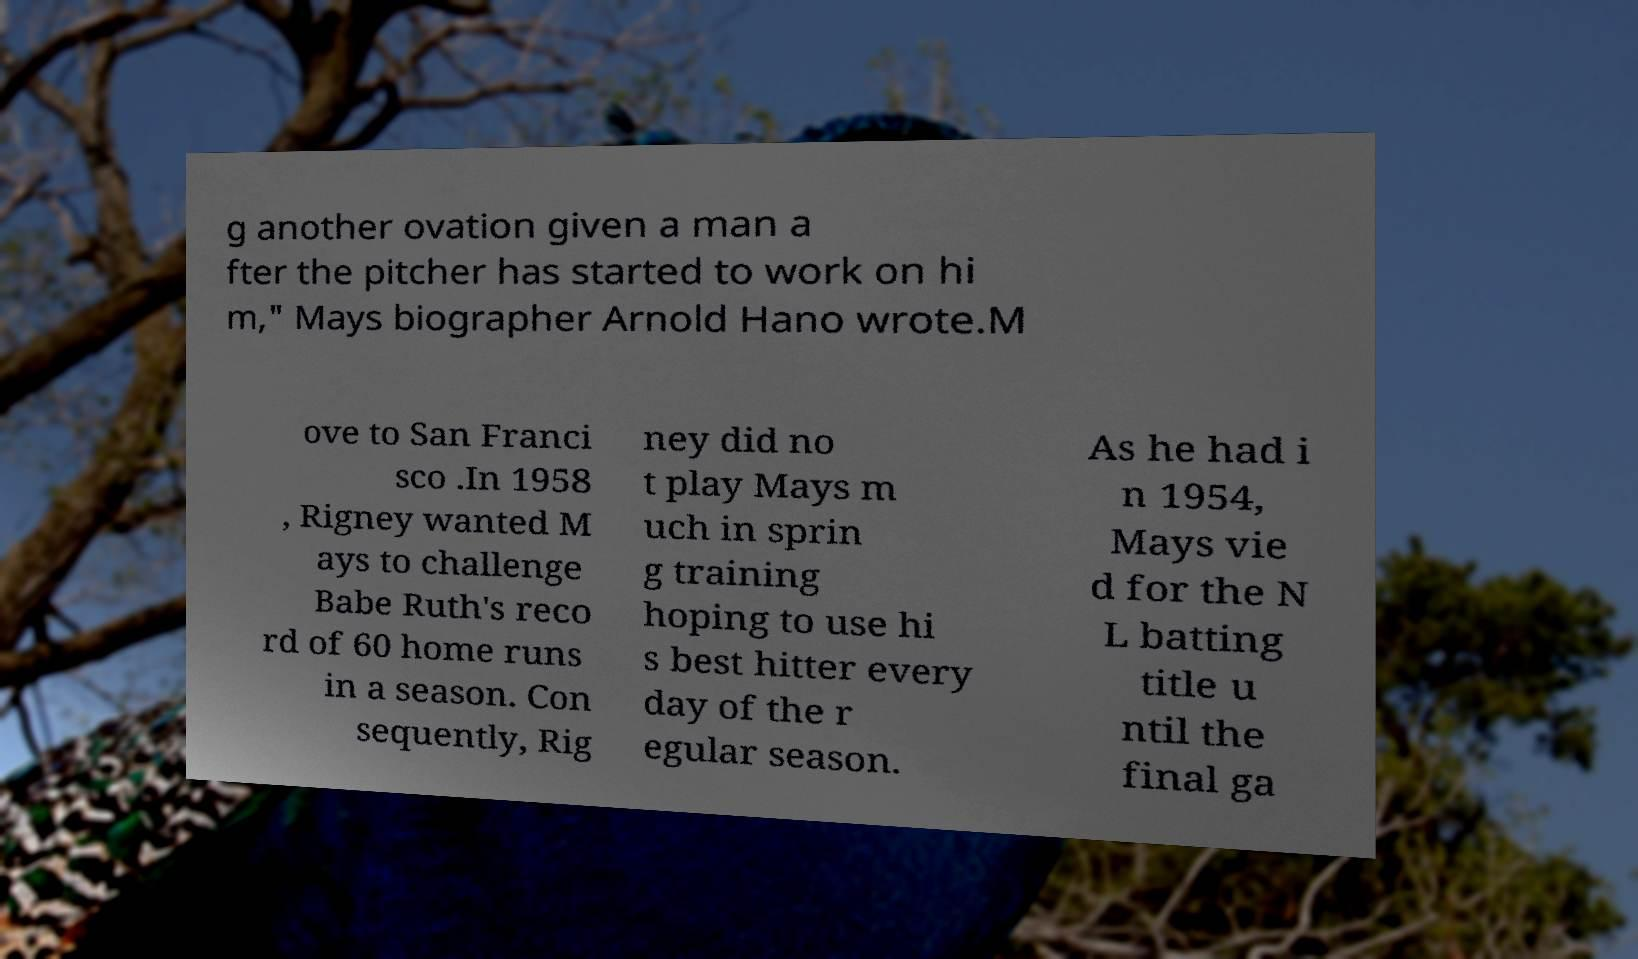Could you assist in decoding the text presented in this image and type it out clearly? g another ovation given a man a fter the pitcher has started to work on hi m," Mays biographer Arnold Hano wrote.M ove to San Franci sco .In 1958 , Rigney wanted M ays to challenge Babe Ruth's reco rd of 60 home runs in a season. Con sequently, Rig ney did no t play Mays m uch in sprin g training hoping to use hi s best hitter every day of the r egular season. As he had i n 1954, Mays vie d for the N L batting title u ntil the final ga 